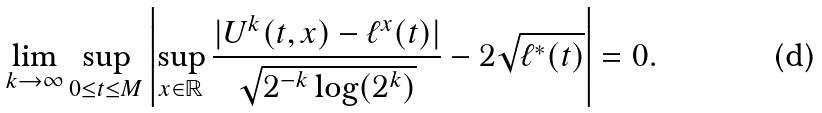Convert formula to latex. <formula><loc_0><loc_0><loc_500><loc_500>\lim _ { k \rightarrow \infty } \sup _ { 0 \leq t \leq M } \left | \sup _ { x \in \mathbb { R } } \frac { | U ^ { k } ( t , x ) - \ell ^ { x } ( t ) | } { \sqrt { 2 ^ { - k } \log ( 2 ^ { k } ) } } - 2 \sqrt { \ell ^ { * } ( t ) } \right | = 0 .</formula> 